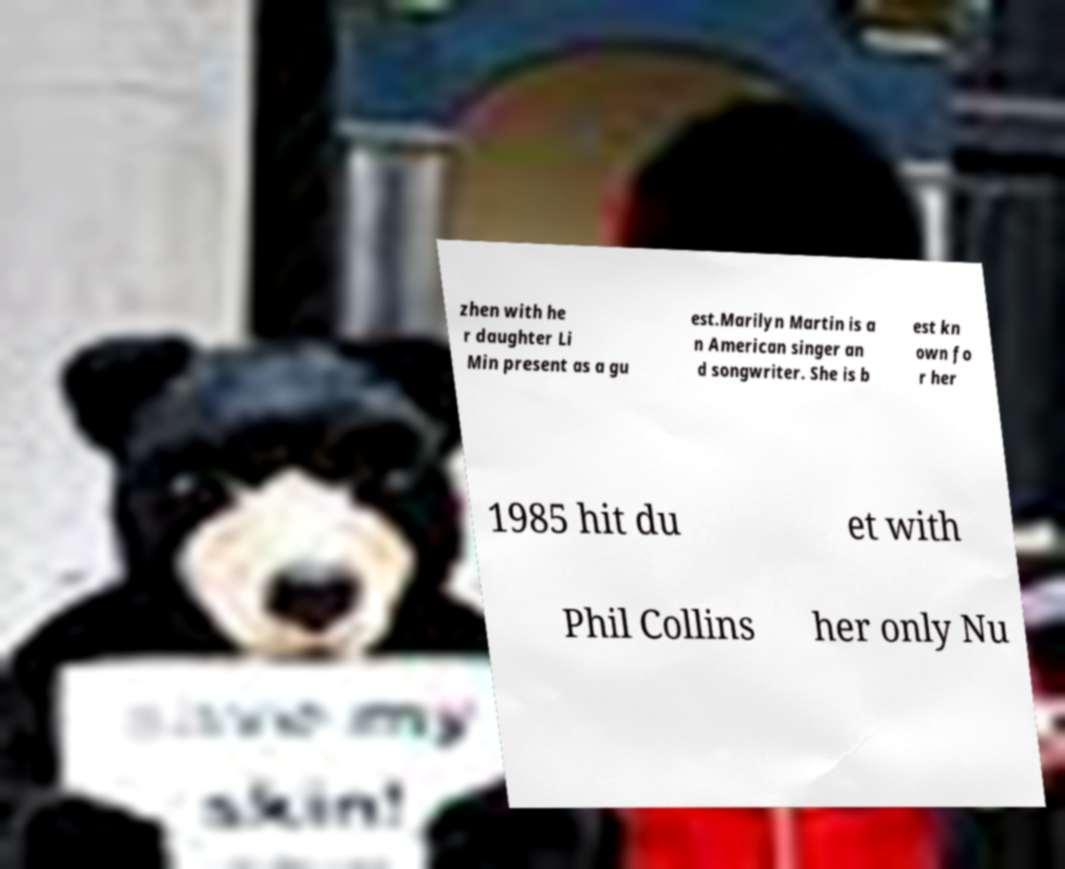Can you accurately transcribe the text from the provided image for me? zhen with he r daughter Li Min present as a gu est.Marilyn Martin is a n American singer an d songwriter. She is b est kn own fo r her 1985 hit du et with Phil Collins her only Nu 